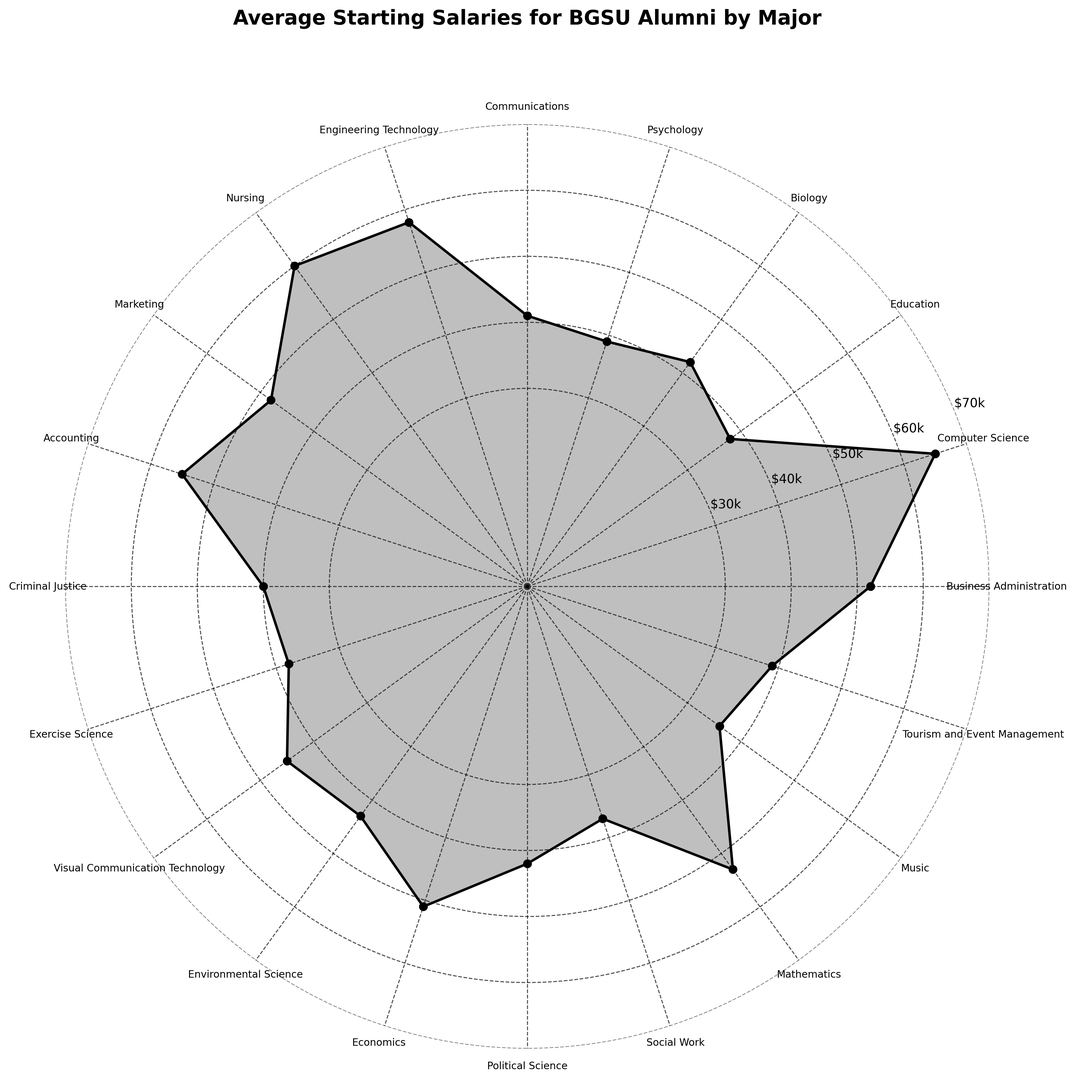Which major has the highest average starting salary? The highest average starting salary can be identified by looking for the peak value in the plot. In this case, the highest value corresponds to Computer Science ($65,000).
Answer: Computer Science Which major has the lowest average starting salary? The lowest average starting salary is found by identifying the smallest value in the plot. The lowest value is associated with Music ($36,000).
Answer: Music What is the average of the highest five starting salaries? To find this, identify the five highest salaries: Computer Science ($65,000), Nursing ($60,000), Engineering Technology ($58,000), Accounting ($55,000), and Mathematics ($53,000). Add them together ($65,000 + $60,000 + $58,000 + $55,000 + $53,000 = $291,000) and then divide by 5 ($291,000 / 5).
Answer: $58,200 How much more do Engineering Technology graduates make compared to Biology graduates? Find the average starting salaries for both majors (Engineering Technology: $58,000 and Biology: $42,000). Subtract the Biology salary from the Engineering Technology salary ($58,000 - $42,000).
Answer: $16,000 Are there any majors with starting salaries of exactly $39,000? Look for the majors that align with the $39,000 value in the plot. Psychology and Tourism and Event Management both have starting salaries of $39,000.
Answer: Psychology, Tourism and Event Management What is the combined average salary of Education, Criminal Justice, and Social Work graduates? First, identify the salaries: Education ($38,000), Criminal Justice ($40,000), and Social Work ($37,000). Add these together ($38,000 + $40,000 + $37,000 = $115,000) and divide by 3 ($115,000 / 3).
Answer: $38,333 Which major has a starting salary closest to the average starting salary of Economics graduates? The average starting salary for Economics is $51,000. Identify the major with a salary closest to $51,000 by visually inspecting the plot. Business Administration (closer) and Marketing ($48,000) are both quite near $51,000, but Business Administration ($52,000) is slightly closer.
Answer: Business Administration Do any majors have starting salaries between $45,000 and $50,000? Identify which majors fall within this range by inspecting the plot. Visual Communication Technology ($45,000) and Marketing ($48,000) both fit this criterion.
Answer: Visual Communication Technology, Marketing 